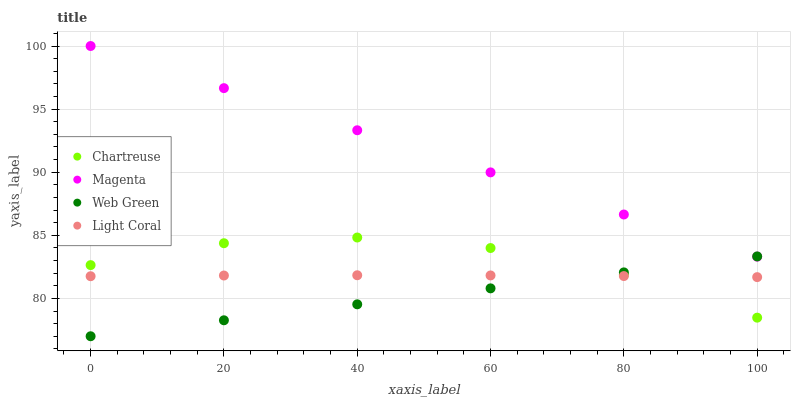Does Web Green have the minimum area under the curve?
Answer yes or no. Yes. Does Magenta have the maximum area under the curve?
Answer yes or no. Yes. Does Chartreuse have the minimum area under the curve?
Answer yes or no. No. Does Chartreuse have the maximum area under the curve?
Answer yes or no. No. Is Web Green the smoothest?
Answer yes or no. Yes. Is Chartreuse the roughest?
Answer yes or no. Yes. Is Magenta the smoothest?
Answer yes or no. No. Is Magenta the roughest?
Answer yes or no. No. Does Web Green have the lowest value?
Answer yes or no. Yes. Does Chartreuse have the lowest value?
Answer yes or no. No. Does Magenta have the highest value?
Answer yes or no. Yes. Does Chartreuse have the highest value?
Answer yes or no. No. Is Chartreuse less than Magenta?
Answer yes or no. Yes. Is Magenta greater than Light Coral?
Answer yes or no. Yes. Does Web Green intersect Chartreuse?
Answer yes or no. Yes. Is Web Green less than Chartreuse?
Answer yes or no. No. Is Web Green greater than Chartreuse?
Answer yes or no. No. Does Chartreuse intersect Magenta?
Answer yes or no. No. 